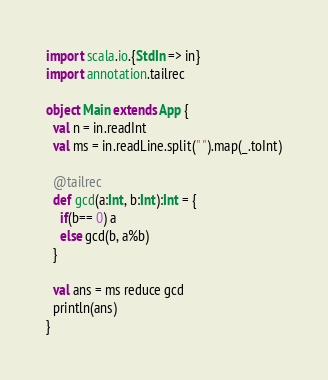Convert code to text. <code><loc_0><loc_0><loc_500><loc_500><_Scala_>import scala.io.{StdIn => in}
import annotation.tailrec

object Main extends App {
  val n = in.readInt
  val ms = in.readLine.split(" ").map(_.toInt)

  @tailrec
  def gcd(a:Int, b:Int):Int = {
    if(b== 0) a
    else gcd(b, a%b)
  }

  val ans = ms reduce gcd
  println(ans)
}</code> 